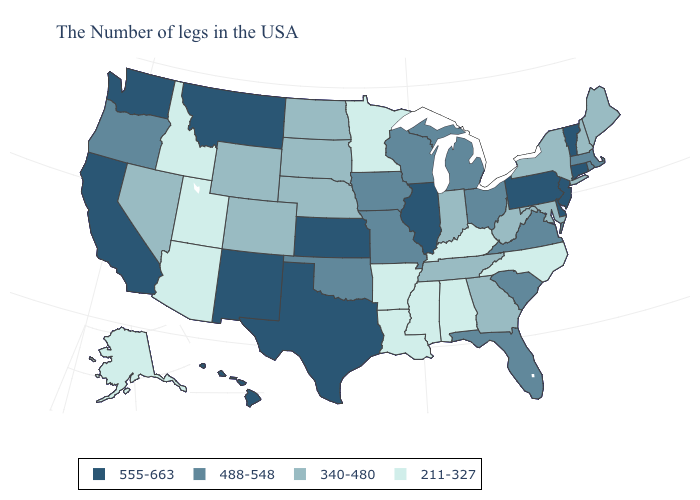Does Rhode Island have a higher value than Georgia?
Short answer required. Yes. Name the states that have a value in the range 488-548?
Write a very short answer. Massachusetts, Rhode Island, Virginia, South Carolina, Ohio, Florida, Michigan, Wisconsin, Missouri, Iowa, Oklahoma, Oregon. Name the states that have a value in the range 555-663?
Be succinct. Vermont, Connecticut, New Jersey, Delaware, Pennsylvania, Illinois, Kansas, Texas, New Mexico, Montana, California, Washington, Hawaii. Which states hav the highest value in the West?
Write a very short answer. New Mexico, Montana, California, Washington, Hawaii. What is the lowest value in states that border Oklahoma?
Give a very brief answer. 211-327. Does Washington have the highest value in the West?
Write a very short answer. Yes. What is the value of Kansas?
Keep it brief. 555-663. Name the states that have a value in the range 555-663?
Give a very brief answer. Vermont, Connecticut, New Jersey, Delaware, Pennsylvania, Illinois, Kansas, Texas, New Mexico, Montana, California, Washington, Hawaii. What is the value of New Hampshire?
Answer briefly. 340-480. Does Alaska have a higher value than Idaho?
Answer briefly. No. Among the states that border South Dakota , does Montana have the highest value?
Keep it brief. Yes. Which states have the lowest value in the South?
Answer briefly. North Carolina, Kentucky, Alabama, Mississippi, Louisiana, Arkansas. What is the value of South Carolina?
Short answer required. 488-548. Name the states that have a value in the range 211-327?
Short answer required. North Carolina, Kentucky, Alabama, Mississippi, Louisiana, Arkansas, Minnesota, Utah, Arizona, Idaho, Alaska. What is the highest value in the Northeast ?
Concise answer only. 555-663. 